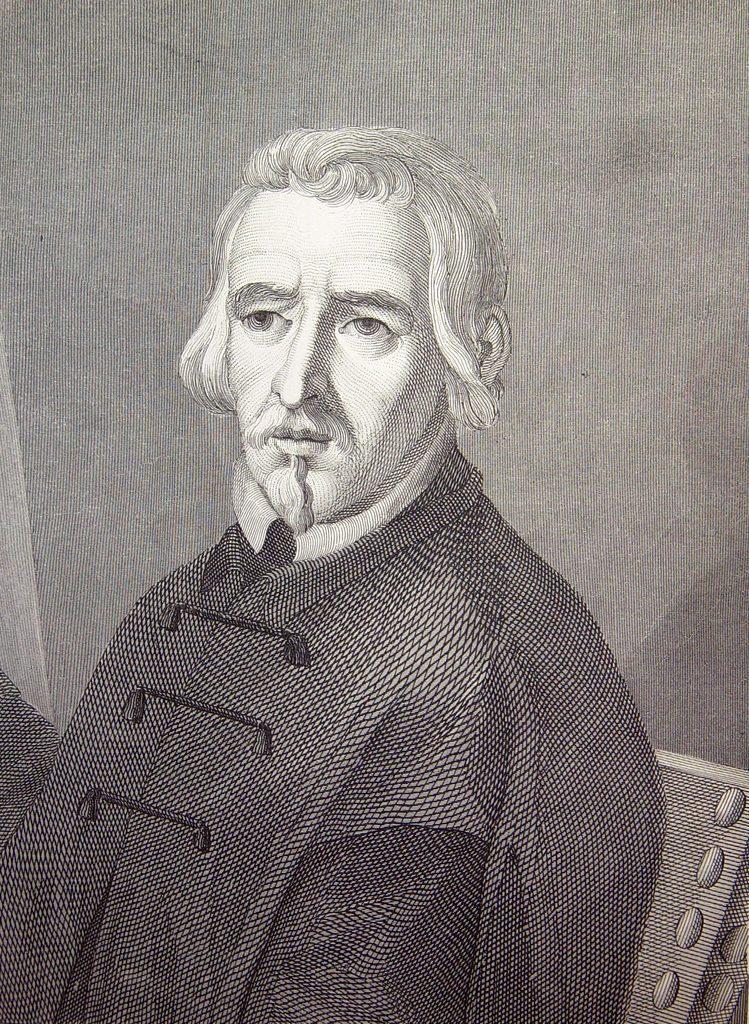Can you describe this image briefly? Sketch picture of a person. Background there is a wall. 